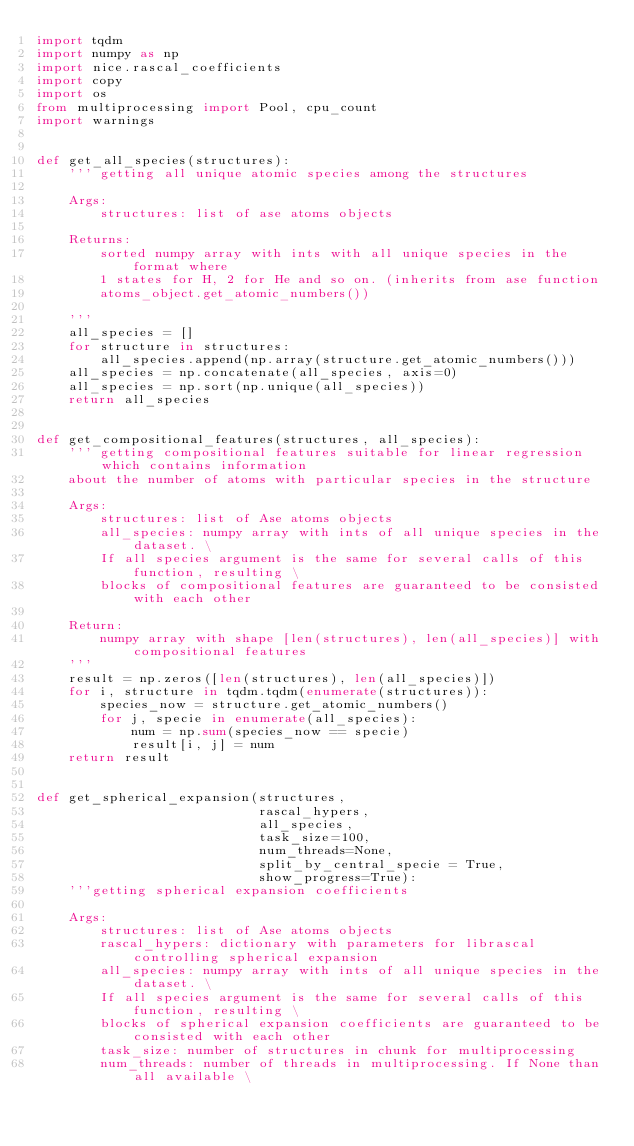Convert code to text. <code><loc_0><loc_0><loc_500><loc_500><_Python_>import tqdm
import numpy as np
import nice.rascal_coefficients
import copy
import os
from multiprocessing import Pool, cpu_count
import warnings


def get_all_species(structures):
    ''' getting all unique atomic species among the structures
    
    Args:
        structures: list of ase atoms objects
        
    Returns:
        sorted numpy array with ints with all unique species in the format where 
        1 states for H, 2 for He and so on. (inherits from ase function 
        atoms_object.get_atomic_numbers())
        
    '''
    all_species = []
    for structure in structures:
        all_species.append(np.array(structure.get_atomic_numbers()))
    all_species = np.concatenate(all_species, axis=0)
    all_species = np.sort(np.unique(all_species))
    return all_species


def get_compositional_features(structures, all_species):
    ''' getting compositional features suitable for linear regression which contains information
    about the number of atoms with particular species in the structure
    
    Args:
        structures: list of Ase atoms objects
        all_species: numpy array with ints of all unique species in the dataset. \
        If all species argument is the same for several calls of this function, resulting \
        blocks of compositional features are guaranteed to be consisted with each other
        
    Return:
        numpy array with shape [len(structures), len(all_species)] with compositional features
    '''
    result = np.zeros([len(structures), len(all_species)])
    for i, structure in tqdm.tqdm(enumerate(structures)):
        species_now = structure.get_atomic_numbers()
        for j, specie in enumerate(all_species):
            num = np.sum(species_now == specie)
            result[i, j] = num
    return result


def get_spherical_expansion(structures,
                            rascal_hypers,
                            all_species,
                            task_size=100,
                            num_threads=None,
                            split_by_central_specie = True,
                            show_progress=True):
    '''getting spherical expansion coefficients
    
    Args:
        structures: list of Ase atoms objects        
        rascal_hypers: dictionary with parameters for librascal controlling spherical expansion        
        all_species: numpy array with ints of all unique species in the dataset. \
        If all species argument is the same for several calls of this function, resulting \
        blocks of spherical expansion coefficients are guaranteed to be consisted with each other
        task_size: number of structures in chunk for multiprocessing
        num_threads: number of threads in multiprocessing. If None than all available \</code> 